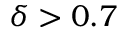<formula> <loc_0><loc_0><loc_500><loc_500>\delta > 0 . 7</formula> 